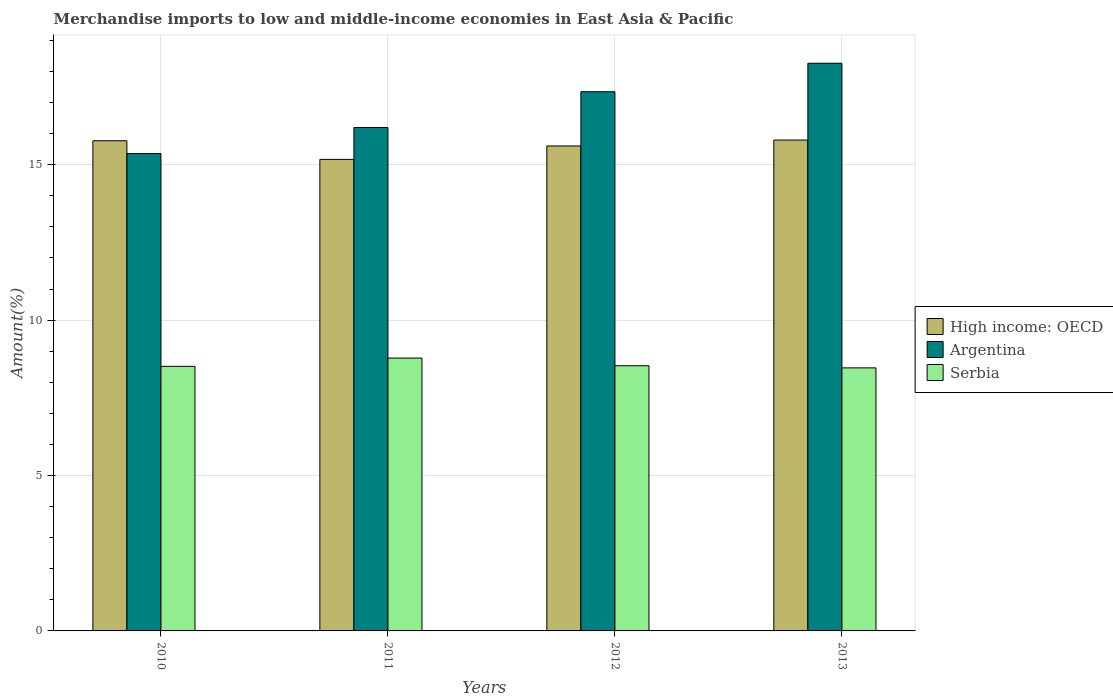Are the number of bars per tick equal to the number of legend labels?
Make the answer very short. Yes. Are the number of bars on each tick of the X-axis equal?
Give a very brief answer. Yes. What is the label of the 4th group of bars from the left?
Your answer should be very brief. 2013. What is the percentage of amount earned from merchandise imports in Argentina in 2010?
Make the answer very short. 15.36. Across all years, what is the maximum percentage of amount earned from merchandise imports in Serbia?
Offer a terse response. 8.78. Across all years, what is the minimum percentage of amount earned from merchandise imports in Argentina?
Provide a short and direct response. 15.36. In which year was the percentage of amount earned from merchandise imports in High income: OECD maximum?
Keep it short and to the point. 2013. What is the total percentage of amount earned from merchandise imports in Serbia in the graph?
Ensure brevity in your answer.  34.29. What is the difference between the percentage of amount earned from merchandise imports in Serbia in 2010 and that in 2013?
Make the answer very short. 0.05. What is the difference between the percentage of amount earned from merchandise imports in Serbia in 2011 and the percentage of amount earned from merchandise imports in High income: OECD in 2013?
Offer a very short reply. -7.01. What is the average percentage of amount earned from merchandise imports in High income: OECD per year?
Your answer should be compact. 15.58. In the year 2010, what is the difference between the percentage of amount earned from merchandise imports in High income: OECD and percentage of amount earned from merchandise imports in Serbia?
Your answer should be compact. 7.26. What is the ratio of the percentage of amount earned from merchandise imports in Serbia in 2010 to that in 2012?
Provide a short and direct response. 1. What is the difference between the highest and the second highest percentage of amount earned from merchandise imports in Argentina?
Make the answer very short. 0.92. What is the difference between the highest and the lowest percentage of amount earned from merchandise imports in High income: OECD?
Offer a very short reply. 0.62. In how many years, is the percentage of amount earned from merchandise imports in Argentina greater than the average percentage of amount earned from merchandise imports in Argentina taken over all years?
Your answer should be compact. 2. Is the sum of the percentage of amount earned from merchandise imports in High income: OECD in 2010 and 2012 greater than the maximum percentage of amount earned from merchandise imports in Serbia across all years?
Provide a short and direct response. Yes. What does the 3rd bar from the left in 2011 represents?
Give a very brief answer. Serbia. Is it the case that in every year, the sum of the percentage of amount earned from merchandise imports in Serbia and percentage of amount earned from merchandise imports in Argentina is greater than the percentage of amount earned from merchandise imports in High income: OECD?
Your response must be concise. Yes. How many bars are there?
Offer a very short reply. 12. How many years are there in the graph?
Provide a short and direct response. 4. How many legend labels are there?
Provide a succinct answer. 3. How are the legend labels stacked?
Your response must be concise. Vertical. What is the title of the graph?
Your answer should be very brief. Merchandise imports to low and middle-income economies in East Asia & Pacific. Does "Estonia" appear as one of the legend labels in the graph?
Offer a terse response. No. What is the label or title of the X-axis?
Ensure brevity in your answer.  Years. What is the label or title of the Y-axis?
Provide a short and direct response. Amount(%). What is the Amount(%) in High income: OECD in 2010?
Ensure brevity in your answer.  15.77. What is the Amount(%) in Argentina in 2010?
Your response must be concise. 15.36. What is the Amount(%) in Serbia in 2010?
Your response must be concise. 8.51. What is the Amount(%) of High income: OECD in 2011?
Provide a succinct answer. 15.17. What is the Amount(%) in Argentina in 2011?
Your answer should be compact. 16.2. What is the Amount(%) in Serbia in 2011?
Provide a short and direct response. 8.78. What is the Amount(%) in High income: OECD in 2012?
Make the answer very short. 15.6. What is the Amount(%) in Argentina in 2012?
Give a very brief answer. 17.35. What is the Amount(%) of Serbia in 2012?
Offer a terse response. 8.53. What is the Amount(%) of High income: OECD in 2013?
Make the answer very short. 15.79. What is the Amount(%) of Argentina in 2013?
Your answer should be compact. 18.26. What is the Amount(%) of Serbia in 2013?
Your response must be concise. 8.46. Across all years, what is the maximum Amount(%) in High income: OECD?
Give a very brief answer. 15.79. Across all years, what is the maximum Amount(%) of Argentina?
Your response must be concise. 18.26. Across all years, what is the maximum Amount(%) in Serbia?
Make the answer very short. 8.78. Across all years, what is the minimum Amount(%) in High income: OECD?
Your response must be concise. 15.17. Across all years, what is the minimum Amount(%) in Argentina?
Give a very brief answer. 15.36. Across all years, what is the minimum Amount(%) in Serbia?
Provide a short and direct response. 8.46. What is the total Amount(%) of High income: OECD in the graph?
Give a very brief answer. 62.34. What is the total Amount(%) in Argentina in the graph?
Your response must be concise. 67.17. What is the total Amount(%) of Serbia in the graph?
Provide a succinct answer. 34.29. What is the difference between the Amount(%) of High income: OECD in 2010 and that in 2011?
Your response must be concise. 0.6. What is the difference between the Amount(%) of Argentina in 2010 and that in 2011?
Make the answer very short. -0.84. What is the difference between the Amount(%) of Serbia in 2010 and that in 2011?
Provide a short and direct response. -0.27. What is the difference between the Amount(%) of High income: OECD in 2010 and that in 2012?
Ensure brevity in your answer.  0.17. What is the difference between the Amount(%) in Argentina in 2010 and that in 2012?
Offer a terse response. -1.99. What is the difference between the Amount(%) of Serbia in 2010 and that in 2012?
Give a very brief answer. -0.02. What is the difference between the Amount(%) in High income: OECD in 2010 and that in 2013?
Your response must be concise. -0.02. What is the difference between the Amount(%) in Argentina in 2010 and that in 2013?
Offer a very short reply. -2.91. What is the difference between the Amount(%) in Serbia in 2010 and that in 2013?
Give a very brief answer. 0.05. What is the difference between the Amount(%) in High income: OECD in 2011 and that in 2012?
Keep it short and to the point. -0.43. What is the difference between the Amount(%) of Argentina in 2011 and that in 2012?
Your answer should be compact. -1.15. What is the difference between the Amount(%) of Serbia in 2011 and that in 2012?
Make the answer very short. 0.25. What is the difference between the Amount(%) in High income: OECD in 2011 and that in 2013?
Ensure brevity in your answer.  -0.62. What is the difference between the Amount(%) of Argentina in 2011 and that in 2013?
Ensure brevity in your answer.  -2.07. What is the difference between the Amount(%) in Serbia in 2011 and that in 2013?
Offer a very short reply. 0.32. What is the difference between the Amount(%) of High income: OECD in 2012 and that in 2013?
Make the answer very short. -0.19. What is the difference between the Amount(%) of Argentina in 2012 and that in 2013?
Offer a very short reply. -0.92. What is the difference between the Amount(%) of Serbia in 2012 and that in 2013?
Give a very brief answer. 0.07. What is the difference between the Amount(%) of High income: OECD in 2010 and the Amount(%) of Argentina in 2011?
Ensure brevity in your answer.  -0.43. What is the difference between the Amount(%) in High income: OECD in 2010 and the Amount(%) in Serbia in 2011?
Make the answer very short. 6.99. What is the difference between the Amount(%) of Argentina in 2010 and the Amount(%) of Serbia in 2011?
Offer a terse response. 6.58. What is the difference between the Amount(%) in High income: OECD in 2010 and the Amount(%) in Argentina in 2012?
Ensure brevity in your answer.  -1.58. What is the difference between the Amount(%) of High income: OECD in 2010 and the Amount(%) of Serbia in 2012?
Make the answer very short. 7.24. What is the difference between the Amount(%) in Argentina in 2010 and the Amount(%) in Serbia in 2012?
Ensure brevity in your answer.  6.83. What is the difference between the Amount(%) in High income: OECD in 2010 and the Amount(%) in Argentina in 2013?
Provide a short and direct response. -2.49. What is the difference between the Amount(%) in High income: OECD in 2010 and the Amount(%) in Serbia in 2013?
Your response must be concise. 7.31. What is the difference between the Amount(%) in Argentina in 2010 and the Amount(%) in Serbia in 2013?
Give a very brief answer. 6.89. What is the difference between the Amount(%) in High income: OECD in 2011 and the Amount(%) in Argentina in 2012?
Your answer should be very brief. -2.18. What is the difference between the Amount(%) in High income: OECD in 2011 and the Amount(%) in Serbia in 2012?
Offer a terse response. 6.64. What is the difference between the Amount(%) of Argentina in 2011 and the Amount(%) of Serbia in 2012?
Your response must be concise. 7.67. What is the difference between the Amount(%) of High income: OECD in 2011 and the Amount(%) of Argentina in 2013?
Provide a short and direct response. -3.09. What is the difference between the Amount(%) of High income: OECD in 2011 and the Amount(%) of Serbia in 2013?
Provide a succinct answer. 6.71. What is the difference between the Amount(%) of Argentina in 2011 and the Amount(%) of Serbia in 2013?
Provide a short and direct response. 7.73. What is the difference between the Amount(%) of High income: OECD in 2012 and the Amount(%) of Argentina in 2013?
Give a very brief answer. -2.66. What is the difference between the Amount(%) of High income: OECD in 2012 and the Amount(%) of Serbia in 2013?
Provide a succinct answer. 7.14. What is the difference between the Amount(%) of Argentina in 2012 and the Amount(%) of Serbia in 2013?
Give a very brief answer. 8.88. What is the average Amount(%) in High income: OECD per year?
Keep it short and to the point. 15.58. What is the average Amount(%) of Argentina per year?
Your answer should be compact. 16.79. What is the average Amount(%) in Serbia per year?
Your response must be concise. 8.57. In the year 2010, what is the difference between the Amount(%) of High income: OECD and Amount(%) of Argentina?
Provide a succinct answer. 0.41. In the year 2010, what is the difference between the Amount(%) of High income: OECD and Amount(%) of Serbia?
Offer a terse response. 7.26. In the year 2010, what is the difference between the Amount(%) in Argentina and Amount(%) in Serbia?
Provide a succinct answer. 6.85. In the year 2011, what is the difference between the Amount(%) of High income: OECD and Amount(%) of Argentina?
Make the answer very short. -1.03. In the year 2011, what is the difference between the Amount(%) in High income: OECD and Amount(%) in Serbia?
Ensure brevity in your answer.  6.39. In the year 2011, what is the difference between the Amount(%) in Argentina and Amount(%) in Serbia?
Provide a short and direct response. 7.42. In the year 2012, what is the difference between the Amount(%) in High income: OECD and Amount(%) in Argentina?
Provide a short and direct response. -1.75. In the year 2012, what is the difference between the Amount(%) of High income: OECD and Amount(%) of Serbia?
Offer a terse response. 7.07. In the year 2012, what is the difference between the Amount(%) of Argentina and Amount(%) of Serbia?
Make the answer very short. 8.82. In the year 2013, what is the difference between the Amount(%) in High income: OECD and Amount(%) in Argentina?
Offer a terse response. -2.47. In the year 2013, what is the difference between the Amount(%) in High income: OECD and Amount(%) in Serbia?
Your answer should be compact. 7.33. In the year 2013, what is the difference between the Amount(%) in Argentina and Amount(%) in Serbia?
Your response must be concise. 9.8. What is the ratio of the Amount(%) in High income: OECD in 2010 to that in 2011?
Provide a short and direct response. 1.04. What is the ratio of the Amount(%) of Argentina in 2010 to that in 2011?
Give a very brief answer. 0.95. What is the ratio of the Amount(%) of Serbia in 2010 to that in 2011?
Keep it short and to the point. 0.97. What is the ratio of the Amount(%) of High income: OECD in 2010 to that in 2012?
Keep it short and to the point. 1.01. What is the ratio of the Amount(%) of Argentina in 2010 to that in 2012?
Your answer should be compact. 0.89. What is the ratio of the Amount(%) in Serbia in 2010 to that in 2012?
Offer a terse response. 1. What is the ratio of the Amount(%) in Argentina in 2010 to that in 2013?
Offer a very short reply. 0.84. What is the ratio of the Amount(%) of High income: OECD in 2011 to that in 2012?
Offer a terse response. 0.97. What is the ratio of the Amount(%) of Argentina in 2011 to that in 2012?
Your answer should be very brief. 0.93. What is the ratio of the Amount(%) in High income: OECD in 2011 to that in 2013?
Offer a very short reply. 0.96. What is the ratio of the Amount(%) of Argentina in 2011 to that in 2013?
Your response must be concise. 0.89. What is the ratio of the Amount(%) in Serbia in 2011 to that in 2013?
Offer a very short reply. 1.04. What is the ratio of the Amount(%) in High income: OECD in 2012 to that in 2013?
Provide a succinct answer. 0.99. What is the ratio of the Amount(%) of Argentina in 2012 to that in 2013?
Your answer should be very brief. 0.95. What is the ratio of the Amount(%) of Serbia in 2012 to that in 2013?
Your answer should be compact. 1.01. What is the difference between the highest and the second highest Amount(%) in High income: OECD?
Give a very brief answer. 0.02. What is the difference between the highest and the second highest Amount(%) in Argentina?
Your response must be concise. 0.92. What is the difference between the highest and the second highest Amount(%) of Serbia?
Your response must be concise. 0.25. What is the difference between the highest and the lowest Amount(%) in High income: OECD?
Offer a very short reply. 0.62. What is the difference between the highest and the lowest Amount(%) in Argentina?
Your response must be concise. 2.91. What is the difference between the highest and the lowest Amount(%) in Serbia?
Keep it short and to the point. 0.32. 